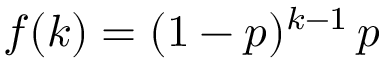Convert formula to latex. <formula><loc_0><loc_0><loc_500><loc_500>f ( k ) = ( 1 - p ) ^ { k - 1 } \, p</formula> 